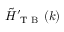Convert formula to latex. <formula><loc_0><loc_0><loc_500><loc_500>\tilde { H } _ { T B } ^ { \prime } ( k )</formula> 